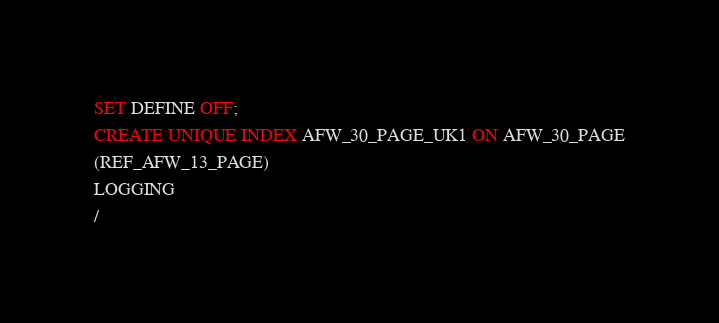<code> <loc_0><loc_0><loc_500><loc_500><_SQL_>SET DEFINE OFF;
CREATE UNIQUE INDEX AFW_30_PAGE_UK1 ON AFW_30_PAGE
(REF_AFW_13_PAGE)
LOGGING
/
</code> 